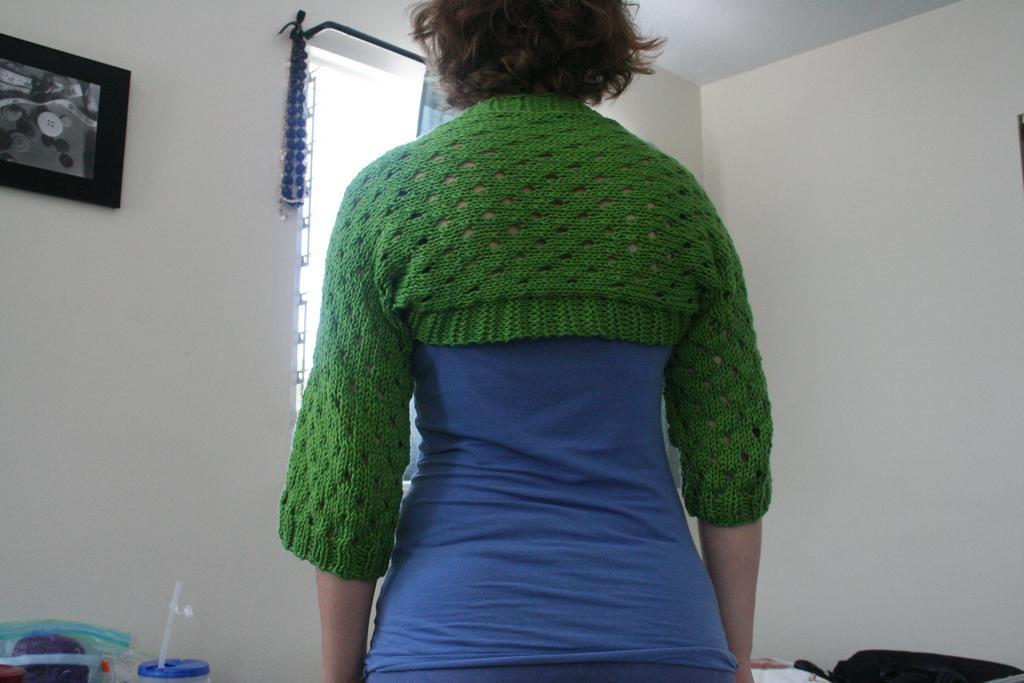Could you give a brief overview of what you see in this image? In the image there is a woman blue t-shirt wearing green shrug, on the left side there is a photograph on the wall with a window in the middle, on the left side bottom there is a soft drink bottle and a cover, on the right side it seems to be a bag on the bed. 